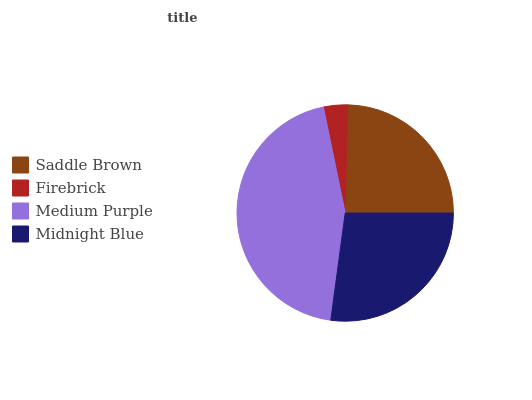Is Firebrick the minimum?
Answer yes or no. Yes. Is Medium Purple the maximum?
Answer yes or no. Yes. Is Medium Purple the minimum?
Answer yes or no. No. Is Firebrick the maximum?
Answer yes or no. No. Is Medium Purple greater than Firebrick?
Answer yes or no. Yes. Is Firebrick less than Medium Purple?
Answer yes or no. Yes. Is Firebrick greater than Medium Purple?
Answer yes or no. No. Is Medium Purple less than Firebrick?
Answer yes or no. No. Is Midnight Blue the high median?
Answer yes or no. Yes. Is Saddle Brown the low median?
Answer yes or no. Yes. Is Medium Purple the high median?
Answer yes or no. No. Is Firebrick the low median?
Answer yes or no. No. 